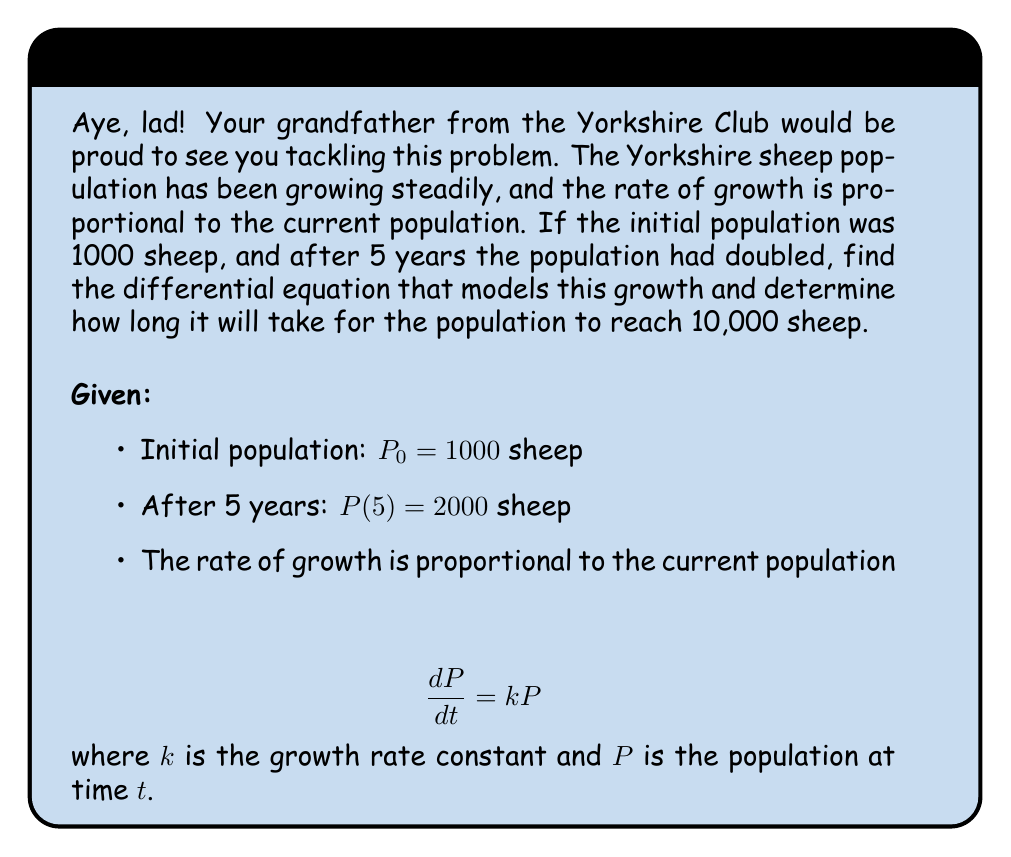Provide a solution to this math problem. Right, let's tackle this step by step:

1) We start with the general solution to the differential equation:
   $$P(t) = P_0e^{kt}$$

2) We know that $P_0 = 1000$ and $P(5) = 2000$. Let's use these to find $k$:
   $$2000 = 1000e^{5k}$$

3) Divide both sides by 1000:
   $$2 = e^{5k}$$

4) Take the natural log of both sides:
   $$\ln 2 = 5k$$

5) Solve for $k$:
   $$k = \frac{\ln 2}{5} \approx 0.1386$$

6) Now we have our complete differential equation:
   $$\frac{dP}{dt} = 0.1386P$$

7) To find when the population reaches 10,000, we use:
   $$10000 = 1000e^{0.1386t}$$

8) Divide both sides by 1000:
   $$10 = e^{0.1386t}$$

9) Take the natural log of both sides:
   $$\ln 10 = 0.1386t$$

10) Solve for $t$:
    $$t = \frac{\ln 10}{0.1386} \approx 16.67$$

Therefore, it will take approximately 16.67 years for the population to reach 10,000 sheep.
Answer: $\frac{dP}{dt} = 0.1386P$; 16.67 years 